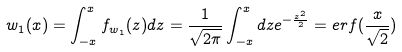Convert formula to latex. <formula><loc_0><loc_0><loc_500><loc_500>w _ { 1 } ( x ) = \int _ { - x } ^ { x } f _ { w _ { 1 } } ( z ) d z = \frac { 1 } { \sqrt { 2 \pi } } \int _ { - x } ^ { x } d z e ^ { - \frac { z ^ { 2 } } { 2 } } = e r f ( \frac { x } { \sqrt { 2 } } )</formula> 